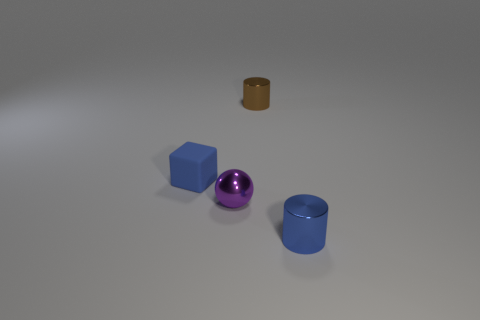Add 2 tiny purple metal things. How many objects exist? 6 Subtract all balls. How many objects are left? 3 Add 3 tiny shiny balls. How many tiny shiny balls are left? 4 Add 1 tiny green rubber spheres. How many tiny green rubber spheres exist? 1 Subtract 0 yellow balls. How many objects are left? 4 Subtract all tiny cylinders. Subtract all blue rubber objects. How many objects are left? 1 